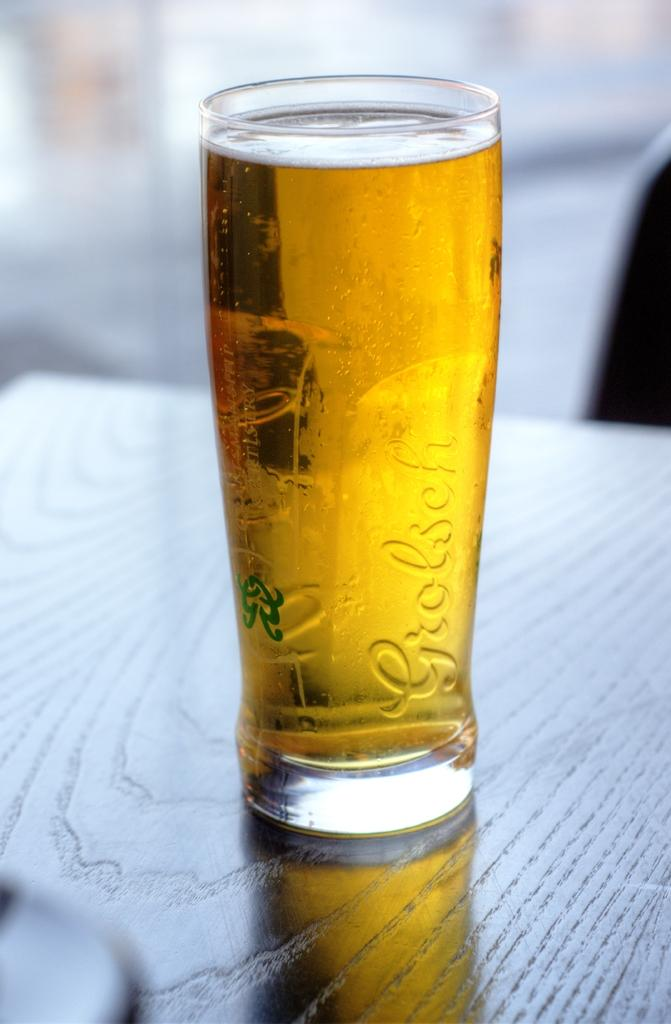<image>
Offer a succinct explanation of the picture presented. A full glass has Grolsch on the side and a green symbol. 